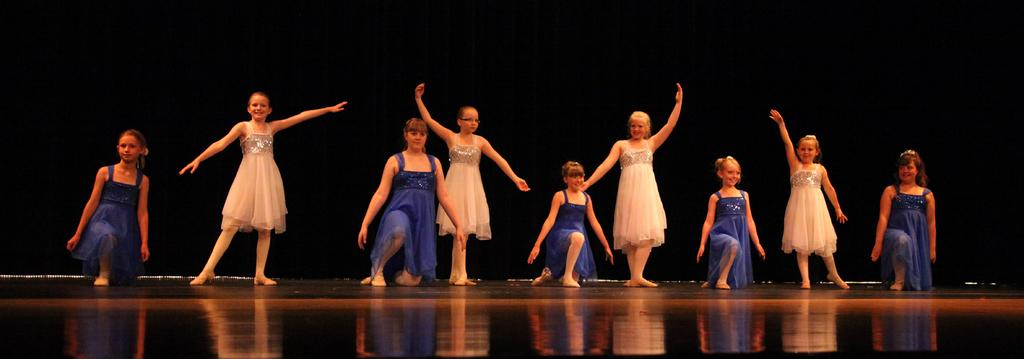What is happening in the foreground of the image? There are girls in the foreground of the image. What are the girls doing in the image? The girls appear to be dancing. What color is the background of the image? The background of the image is black. Can you tell me who is guiding the girls in the image? There is no guide present in the image; the girls are dancing on their own. What type of event is taking place in the cemetery in the image? There is no cemetery present in the image; it features girls dancing in the foreground with a black background. 